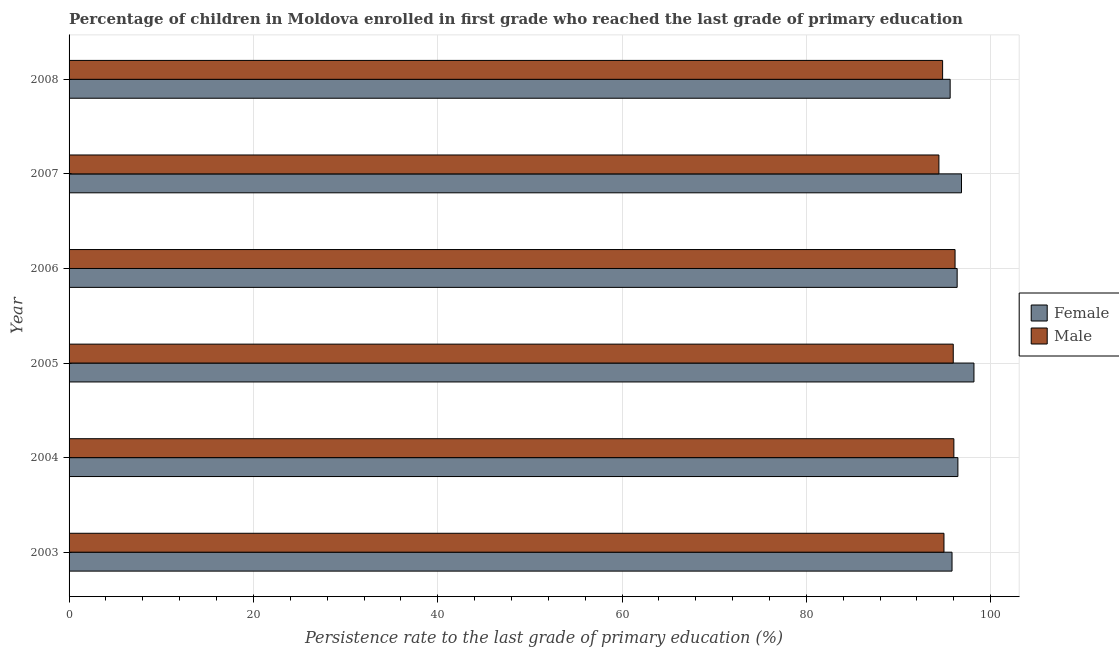How many different coloured bars are there?
Ensure brevity in your answer.  2. Are the number of bars on each tick of the Y-axis equal?
Your answer should be very brief. Yes. How many bars are there on the 3rd tick from the top?
Give a very brief answer. 2. What is the label of the 4th group of bars from the top?
Give a very brief answer. 2005. What is the persistence rate of female students in 2003?
Offer a terse response. 95.8. Across all years, what is the maximum persistence rate of female students?
Offer a very short reply. 98.18. Across all years, what is the minimum persistence rate of female students?
Ensure brevity in your answer.  95.6. What is the total persistence rate of female students in the graph?
Your answer should be very brief. 579.21. What is the difference between the persistence rate of female students in 2005 and that in 2006?
Offer a very short reply. 1.82. What is the difference between the persistence rate of female students in 2006 and the persistence rate of male students in 2008?
Make the answer very short. 1.58. What is the average persistence rate of female students per year?
Your response must be concise. 96.53. In the year 2007, what is the difference between the persistence rate of female students and persistence rate of male students?
Your answer should be compact. 2.45. Is the difference between the persistence rate of male students in 2004 and 2005 greater than the difference between the persistence rate of female students in 2004 and 2005?
Your answer should be compact. Yes. What is the difference between the highest and the second highest persistence rate of female students?
Make the answer very short. 1.35. In how many years, is the persistence rate of male students greater than the average persistence rate of male students taken over all years?
Provide a succinct answer. 3. Is the sum of the persistence rate of female students in 2003 and 2006 greater than the maximum persistence rate of male students across all years?
Your response must be concise. Yes. Are all the bars in the graph horizontal?
Make the answer very short. Yes. What is the difference between two consecutive major ticks on the X-axis?
Provide a short and direct response. 20. Are the values on the major ticks of X-axis written in scientific E-notation?
Your answer should be very brief. No. Does the graph contain any zero values?
Keep it short and to the point. No. How many legend labels are there?
Give a very brief answer. 2. How are the legend labels stacked?
Offer a terse response. Vertical. What is the title of the graph?
Give a very brief answer. Percentage of children in Moldova enrolled in first grade who reached the last grade of primary education. What is the label or title of the X-axis?
Your answer should be very brief. Persistence rate to the last grade of primary education (%). What is the label or title of the Y-axis?
Your response must be concise. Year. What is the Persistence rate to the last grade of primary education (%) of Female in 2003?
Offer a terse response. 95.8. What is the Persistence rate to the last grade of primary education (%) of Male in 2003?
Your response must be concise. 94.93. What is the Persistence rate to the last grade of primary education (%) of Female in 2004?
Give a very brief answer. 96.44. What is the Persistence rate to the last grade of primary education (%) in Male in 2004?
Your response must be concise. 96. What is the Persistence rate to the last grade of primary education (%) in Female in 2005?
Offer a terse response. 98.18. What is the Persistence rate to the last grade of primary education (%) of Male in 2005?
Keep it short and to the point. 95.93. What is the Persistence rate to the last grade of primary education (%) of Female in 2006?
Provide a succinct answer. 96.36. What is the Persistence rate to the last grade of primary education (%) in Male in 2006?
Your response must be concise. 96.13. What is the Persistence rate to the last grade of primary education (%) in Female in 2007?
Offer a terse response. 96.83. What is the Persistence rate to the last grade of primary education (%) of Male in 2007?
Provide a succinct answer. 94.38. What is the Persistence rate to the last grade of primary education (%) in Female in 2008?
Provide a short and direct response. 95.6. What is the Persistence rate to the last grade of primary education (%) of Male in 2008?
Offer a very short reply. 94.78. Across all years, what is the maximum Persistence rate to the last grade of primary education (%) of Female?
Your answer should be very brief. 98.18. Across all years, what is the maximum Persistence rate to the last grade of primary education (%) in Male?
Your response must be concise. 96.13. Across all years, what is the minimum Persistence rate to the last grade of primary education (%) of Female?
Your answer should be very brief. 95.6. Across all years, what is the minimum Persistence rate to the last grade of primary education (%) in Male?
Your response must be concise. 94.38. What is the total Persistence rate to the last grade of primary education (%) in Female in the graph?
Your answer should be compact. 579.21. What is the total Persistence rate to the last grade of primary education (%) in Male in the graph?
Provide a short and direct response. 572.15. What is the difference between the Persistence rate to the last grade of primary education (%) of Female in 2003 and that in 2004?
Give a very brief answer. -0.64. What is the difference between the Persistence rate to the last grade of primary education (%) of Male in 2003 and that in 2004?
Provide a succinct answer. -1.07. What is the difference between the Persistence rate to the last grade of primary education (%) in Female in 2003 and that in 2005?
Your answer should be very brief. -2.38. What is the difference between the Persistence rate to the last grade of primary education (%) of Male in 2003 and that in 2005?
Provide a succinct answer. -1.01. What is the difference between the Persistence rate to the last grade of primary education (%) of Female in 2003 and that in 2006?
Provide a succinct answer. -0.56. What is the difference between the Persistence rate to the last grade of primary education (%) in Male in 2003 and that in 2006?
Your answer should be very brief. -1.2. What is the difference between the Persistence rate to the last grade of primary education (%) of Female in 2003 and that in 2007?
Keep it short and to the point. -1.03. What is the difference between the Persistence rate to the last grade of primary education (%) of Male in 2003 and that in 2007?
Provide a short and direct response. 0.55. What is the difference between the Persistence rate to the last grade of primary education (%) in Female in 2003 and that in 2008?
Your answer should be compact. 0.2. What is the difference between the Persistence rate to the last grade of primary education (%) of Male in 2003 and that in 2008?
Provide a succinct answer. 0.15. What is the difference between the Persistence rate to the last grade of primary education (%) of Female in 2004 and that in 2005?
Your answer should be very brief. -1.74. What is the difference between the Persistence rate to the last grade of primary education (%) in Male in 2004 and that in 2005?
Keep it short and to the point. 0.07. What is the difference between the Persistence rate to the last grade of primary education (%) in Female in 2004 and that in 2006?
Keep it short and to the point. 0.08. What is the difference between the Persistence rate to the last grade of primary education (%) of Male in 2004 and that in 2006?
Your response must be concise. -0.13. What is the difference between the Persistence rate to the last grade of primary education (%) of Female in 2004 and that in 2007?
Offer a terse response. -0.39. What is the difference between the Persistence rate to the last grade of primary education (%) of Male in 2004 and that in 2007?
Give a very brief answer. 1.62. What is the difference between the Persistence rate to the last grade of primary education (%) in Female in 2004 and that in 2008?
Offer a terse response. 0.84. What is the difference between the Persistence rate to the last grade of primary education (%) in Male in 2004 and that in 2008?
Your response must be concise. 1.22. What is the difference between the Persistence rate to the last grade of primary education (%) in Female in 2005 and that in 2006?
Provide a succinct answer. 1.82. What is the difference between the Persistence rate to the last grade of primary education (%) of Male in 2005 and that in 2006?
Ensure brevity in your answer.  -0.2. What is the difference between the Persistence rate to the last grade of primary education (%) in Female in 2005 and that in 2007?
Make the answer very short. 1.35. What is the difference between the Persistence rate to the last grade of primary education (%) of Male in 2005 and that in 2007?
Provide a short and direct response. 1.56. What is the difference between the Persistence rate to the last grade of primary education (%) in Female in 2005 and that in 2008?
Your answer should be compact. 2.58. What is the difference between the Persistence rate to the last grade of primary education (%) of Male in 2005 and that in 2008?
Offer a very short reply. 1.16. What is the difference between the Persistence rate to the last grade of primary education (%) of Female in 2006 and that in 2007?
Offer a terse response. -0.47. What is the difference between the Persistence rate to the last grade of primary education (%) of Male in 2006 and that in 2007?
Keep it short and to the point. 1.75. What is the difference between the Persistence rate to the last grade of primary education (%) of Female in 2006 and that in 2008?
Offer a terse response. 0.76. What is the difference between the Persistence rate to the last grade of primary education (%) in Male in 2006 and that in 2008?
Your answer should be very brief. 1.35. What is the difference between the Persistence rate to the last grade of primary education (%) in Female in 2007 and that in 2008?
Give a very brief answer. 1.23. What is the difference between the Persistence rate to the last grade of primary education (%) of Male in 2007 and that in 2008?
Your answer should be compact. -0.4. What is the difference between the Persistence rate to the last grade of primary education (%) of Female in 2003 and the Persistence rate to the last grade of primary education (%) of Male in 2004?
Your answer should be very brief. -0.2. What is the difference between the Persistence rate to the last grade of primary education (%) in Female in 2003 and the Persistence rate to the last grade of primary education (%) in Male in 2005?
Offer a very short reply. -0.13. What is the difference between the Persistence rate to the last grade of primary education (%) of Female in 2003 and the Persistence rate to the last grade of primary education (%) of Male in 2006?
Your answer should be very brief. -0.33. What is the difference between the Persistence rate to the last grade of primary education (%) in Female in 2003 and the Persistence rate to the last grade of primary education (%) in Male in 2007?
Provide a short and direct response. 1.42. What is the difference between the Persistence rate to the last grade of primary education (%) of Female in 2003 and the Persistence rate to the last grade of primary education (%) of Male in 2008?
Your answer should be compact. 1.02. What is the difference between the Persistence rate to the last grade of primary education (%) of Female in 2004 and the Persistence rate to the last grade of primary education (%) of Male in 2005?
Keep it short and to the point. 0.5. What is the difference between the Persistence rate to the last grade of primary education (%) of Female in 2004 and the Persistence rate to the last grade of primary education (%) of Male in 2006?
Offer a very short reply. 0.31. What is the difference between the Persistence rate to the last grade of primary education (%) of Female in 2004 and the Persistence rate to the last grade of primary education (%) of Male in 2007?
Your response must be concise. 2.06. What is the difference between the Persistence rate to the last grade of primary education (%) in Female in 2004 and the Persistence rate to the last grade of primary education (%) in Male in 2008?
Ensure brevity in your answer.  1.66. What is the difference between the Persistence rate to the last grade of primary education (%) in Female in 2005 and the Persistence rate to the last grade of primary education (%) in Male in 2006?
Your answer should be compact. 2.05. What is the difference between the Persistence rate to the last grade of primary education (%) of Female in 2005 and the Persistence rate to the last grade of primary education (%) of Male in 2007?
Keep it short and to the point. 3.8. What is the difference between the Persistence rate to the last grade of primary education (%) in Female in 2005 and the Persistence rate to the last grade of primary education (%) in Male in 2008?
Make the answer very short. 3.4. What is the difference between the Persistence rate to the last grade of primary education (%) of Female in 2006 and the Persistence rate to the last grade of primary education (%) of Male in 2007?
Offer a terse response. 1.98. What is the difference between the Persistence rate to the last grade of primary education (%) of Female in 2006 and the Persistence rate to the last grade of primary education (%) of Male in 2008?
Make the answer very short. 1.58. What is the difference between the Persistence rate to the last grade of primary education (%) in Female in 2007 and the Persistence rate to the last grade of primary education (%) in Male in 2008?
Give a very brief answer. 2.05. What is the average Persistence rate to the last grade of primary education (%) of Female per year?
Offer a terse response. 96.53. What is the average Persistence rate to the last grade of primary education (%) in Male per year?
Your answer should be very brief. 95.36. In the year 2003, what is the difference between the Persistence rate to the last grade of primary education (%) in Female and Persistence rate to the last grade of primary education (%) in Male?
Offer a very short reply. 0.87. In the year 2004, what is the difference between the Persistence rate to the last grade of primary education (%) of Female and Persistence rate to the last grade of primary education (%) of Male?
Offer a very short reply. 0.43. In the year 2005, what is the difference between the Persistence rate to the last grade of primary education (%) of Female and Persistence rate to the last grade of primary education (%) of Male?
Your answer should be very brief. 2.25. In the year 2006, what is the difference between the Persistence rate to the last grade of primary education (%) in Female and Persistence rate to the last grade of primary education (%) in Male?
Your answer should be very brief. 0.23. In the year 2007, what is the difference between the Persistence rate to the last grade of primary education (%) of Female and Persistence rate to the last grade of primary education (%) of Male?
Provide a succinct answer. 2.45. In the year 2008, what is the difference between the Persistence rate to the last grade of primary education (%) in Female and Persistence rate to the last grade of primary education (%) in Male?
Your answer should be compact. 0.82. What is the ratio of the Persistence rate to the last grade of primary education (%) of Female in 2003 to that in 2004?
Your response must be concise. 0.99. What is the ratio of the Persistence rate to the last grade of primary education (%) of Female in 2003 to that in 2005?
Make the answer very short. 0.98. What is the ratio of the Persistence rate to the last grade of primary education (%) of Male in 2003 to that in 2006?
Your answer should be compact. 0.99. What is the ratio of the Persistence rate to the last grade of primary education (%) in Female in 2003 to that in 2007?
Keep it short and to the point. 0.99. What is the ratio of the Persistence rate to the last grade of primary education (%) in Male in 2003 to that in 2007?
Keep it short and to the point. 1.01. What is the ratio of the Persistence rate to the last grade of primary education (%) in Female in 2004 to that in 2005?
Your response must be concise. 0.98. What is the ratio of the Persistence rate to the last grade of primary education (%) in Male in 2004 to that in 2005?
Offer a very short reply. 1. What is the ratio of the Persistence rate to the last grade of primary education (%) of Female in 2004 to that in 2006?
Give a very brief answer. 1. What is the ratio of the Persistence rate to the last grade of primary education (%) in Male in 2004 to that in 2006?
Give a very brief answer. 1. What is the ratio of the Persistence rate to the last grade of primary education (%) in Female in 2004 to that in 2007?
Provide a succinct answer. 1. What is the ratio of the Persistence rate to the last grade of primary education (%) in Male in 2004 to that in 2007?
Make the answer very short. 1.02. What is the ratio of the Persistence rate to the last grade of primary education (%) of Female in 2004 to that in 2008?
Offer a very short reply. 1.01. What is the ratio of the Persistence rate to the last grade of primary education (%) in Male in 2004 to that in 2008?
Provide a short and direct response. 1.01. What is the ratio of the Persistence rate to the last grade of primary education (%) of Female in 2005 to that in 2006?
Your response must be concise. 1.02. What is the ratio of the Persistence rate to the last grade of primary education (%) in Female in 2005 to that in 2007?
Your answer should be compact. 1.01. What is the ratio of the Persistence rate to the last grade of primary education (%) of Male in 2005 to that in 2007?
Offer a very short reply. 1.02. What is the ratio of the Persistence rate to the last grade of primary education (%) in Male in 2005 to that in 2008?
Provide a short and direct response. 1.01. What is the ratio of the Persistence rate to the last grade of primary education (%) in Female in 2006 to that in 2007?
Make the answer very short. 1. What is the ratio of the Persistence rate to the last grade of primary education (%) of Male in 2006 to that in 2007?
Your answer should be very brief. 1.02. What is the ratio of the Persistence rate to the last grade of primary education (%) in Female in 2006 to that in 2008?
Keep it short and to the point. 1.01. What is the ratio of the Persistence rate to the last grade of primary education (%) in Male in 2006 to that in 2008?
Offer a terse response. 1.01. What is the ratio of the Persistence rate to the last grade of primary education (%) of Female in 2007 to that in 2008?
Provide a succinct answer. 1.01. What is the difference between the highest and the second highest Persistence rate to the last grade of primary education (%) in Female?
Your answer should be compact. 1.35. What is the difference between the highest and the second highest Persistence rate to the last grade of primary education (%) in Male?
Provide a succinct answer. 0.13. What is the difference between the highest and the lowest Persistence rate to the last grade of primary education (%) of Female?
Your answer should be compact. 2.58. What is the difference between the highest and the lowest Persistence rate to the last grade of primary education (%) in Male?
Provide a short and direct response. 1.75. 